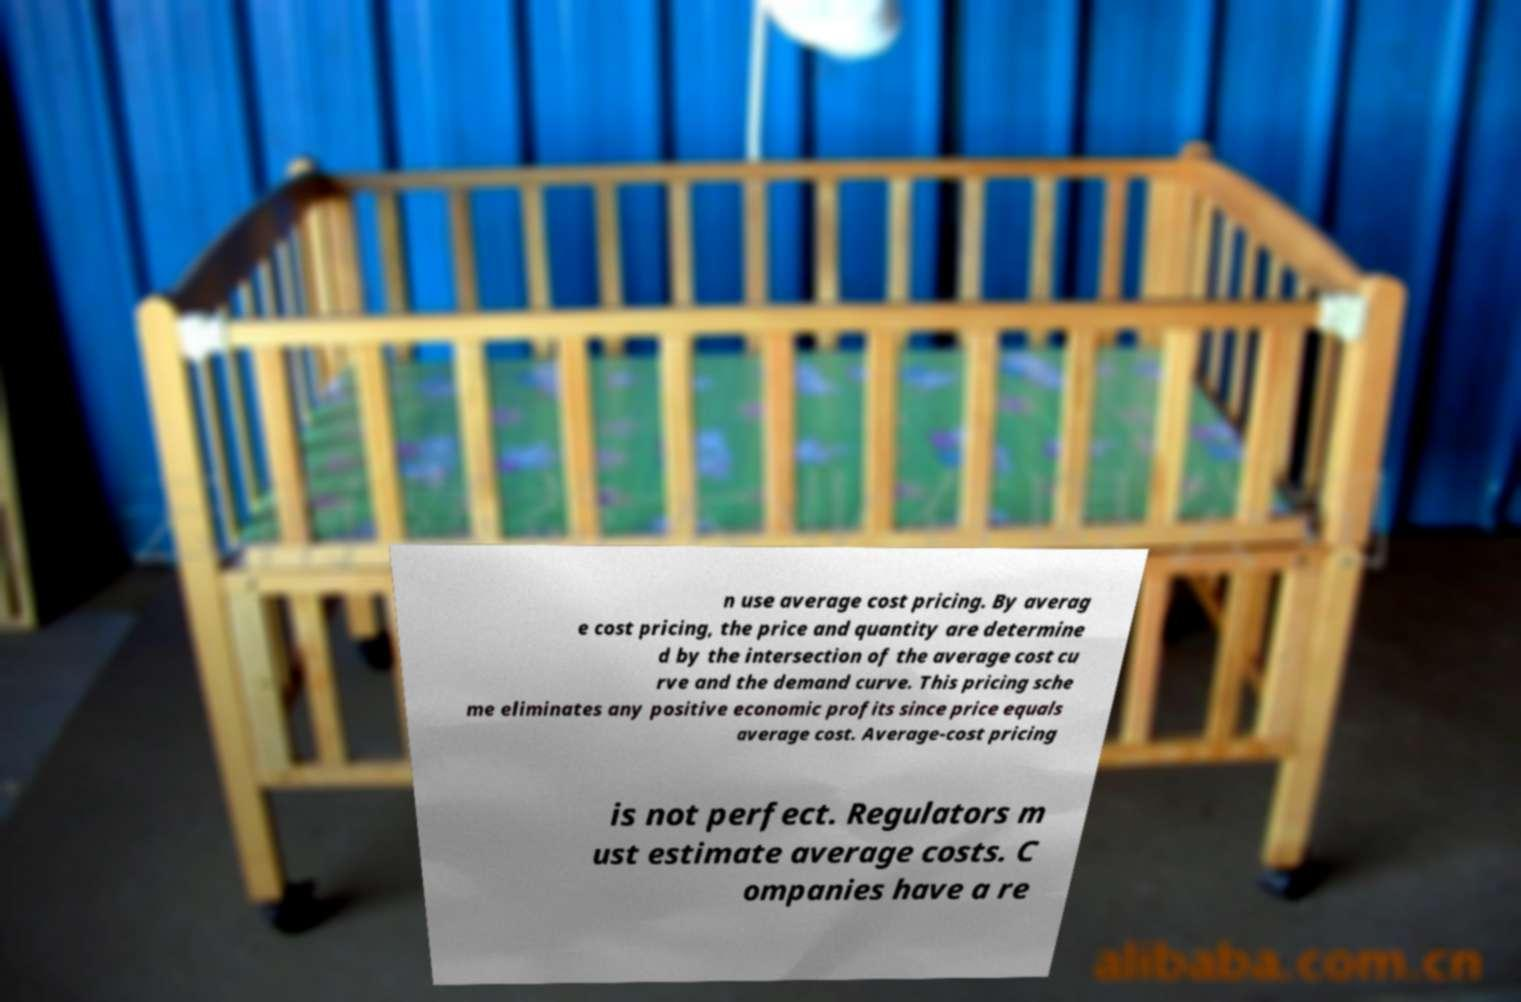Can you read and provide the text displayed in the image?This photo seems to have some interesting text. Can you extract and type it out for me? n use average cost pricing. By averag e cost pricing, the price and quantity are determine d by the intersection of the average cost cu rve and the demand curve. This pricing sche me eliminates any positive economic profits since price equals average cost. Average-cost pricing is not perfect. Regulators m ust estimate average costs. C ompanies have a re 